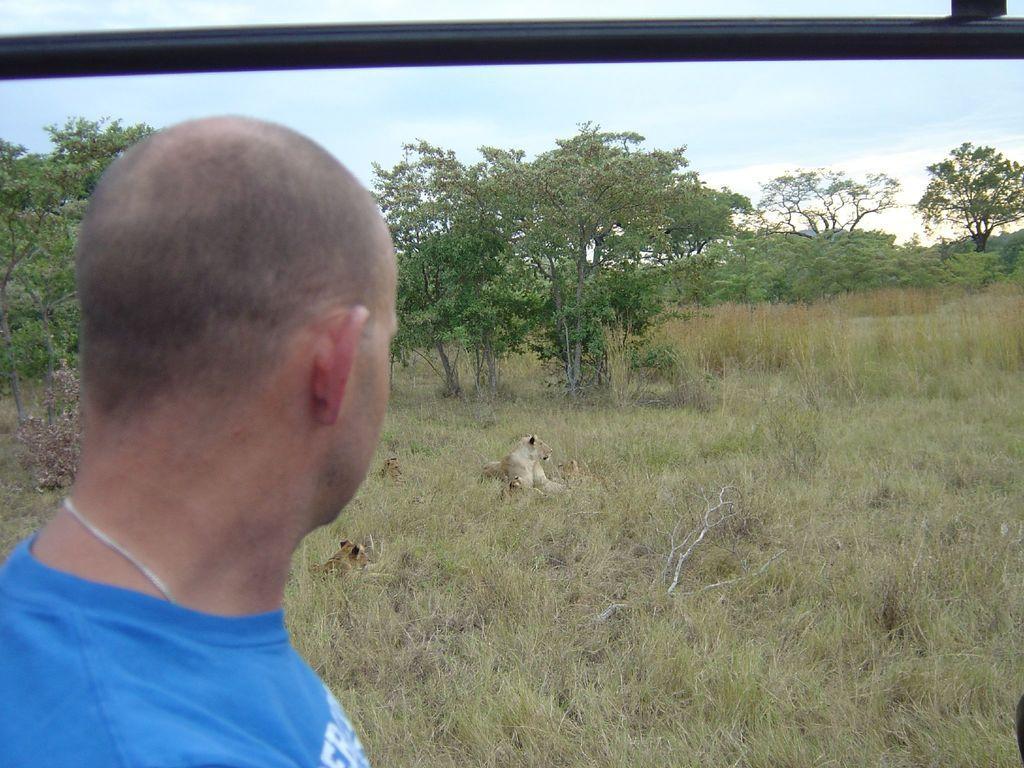Could you give a brief overview of what you see in this image? On the left side of the image we can see a person is standing. At the top of the image, we can see one black color object. In the background, we can see the sky, clouds, trees, grass and animals. 